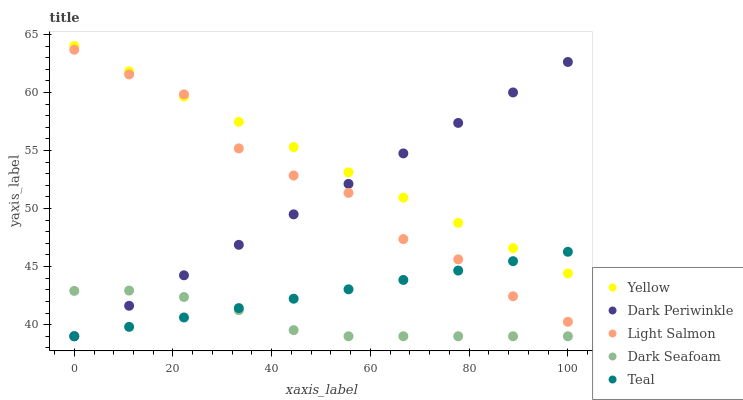Does Dark Seafoam have the minimum area under the curve?
Answer yes or no. Yes. Does Yellow have the maximum area under the curve?
Answer yes or no. Yes. Does Light Salmon have the minimum area under the curve?
Answer yes or no. No. Does Light Salmon have the maximum area under the curve?
Answer yes or no. No. Is Yellow the smoothest?
Answer yes or no. Yes. Is Light Salmon the roughest?
Answer yes or no. Yes. Is Teal the smoothest?
Answer yes or no. No. Is Teal the roughest?
Answer yes or no. No. Does Dark Seafoam have the lowest value?
Answer yes or no. Yes. Does Light Salmon have the lowest value?
Answer yes or no. No. Does Yellow have the highest value?
Answer yes or no. Yes. Does Light Salmon have the highest value?
Answer yes or no. No. Is Dark Seafoam less than Yellow?
Answer yes or no. Yes. Is Light Salmon greater than Dark Seafoam?
Answer yes or no. Yes. Does Dark Seafoam intersect Dark Periwinkle?
Answer yes or no. Yes. Is Dark Seafoam less than Dark Periwinkle?
Answer yes or no. No. Is Dark Seafoam greater than Dark Periwinkle?
Answer yes or no. No. Does Dark Seafoam intersect Yellow?
Answer yes or no. No. 